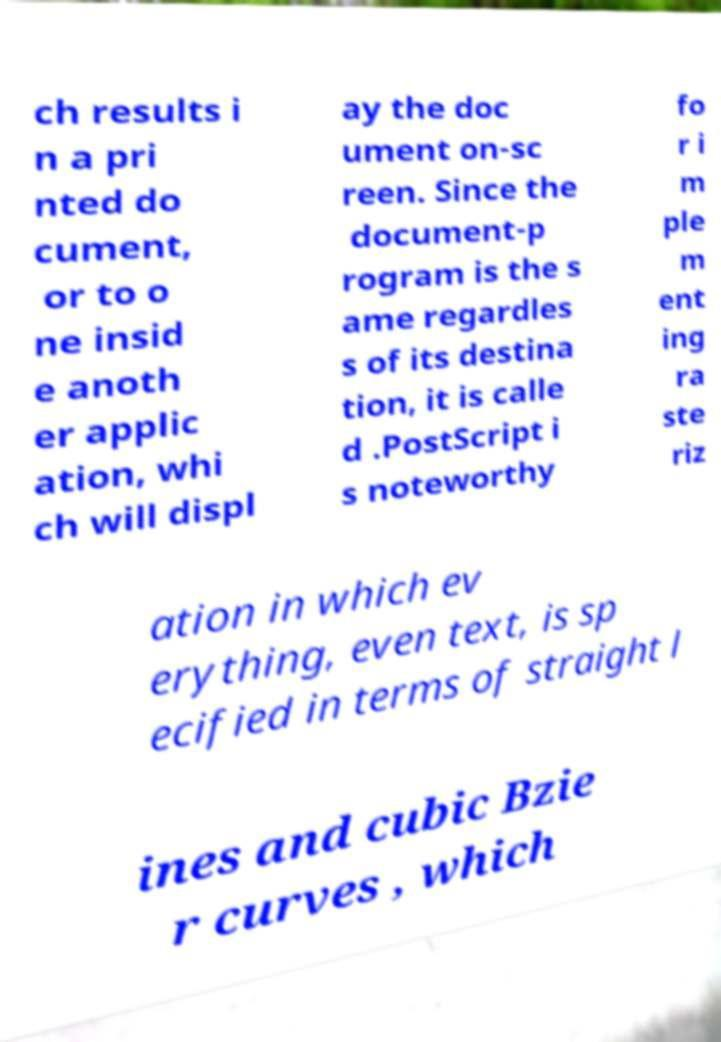What messages or text are displayed in this image? I need them in a readable, typed format. ch results i n a pri nted do cument, or to o ne insid e anoth er applic ation, whi ch will displ ay the doc ument on-sc reen. Since the document-p rogram is the s ame regardles s of its destina tion, it is calle d .PostScript i s noteworthy fo r i m ple m ent ing ra ste riz ation in which ev erything, even text, is sp ecified in terms of straight l ines and cubic Bzie r curves , which 